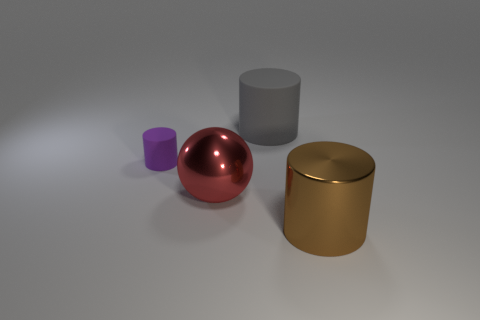What materials do the objects in the image appear to be made of? The objects in the image seem to have surfaces that resemble typical rendering of various materials. The red sphere looks like it could be a polished metal like copper, the closest cylinder has a matte finish similar to plastic, and the golden canister seems to have a reflective surface akin to polished brass. 